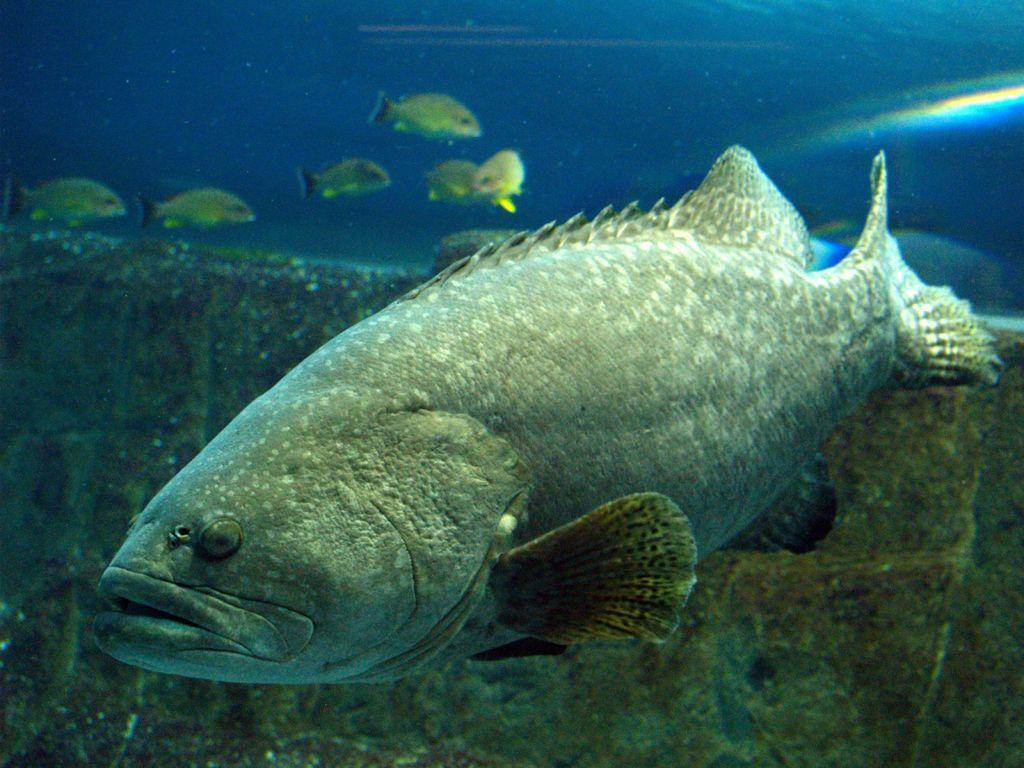In one or two sentences, can you explain what this image depicts? In the given image i can see the fishes and the greenery. 